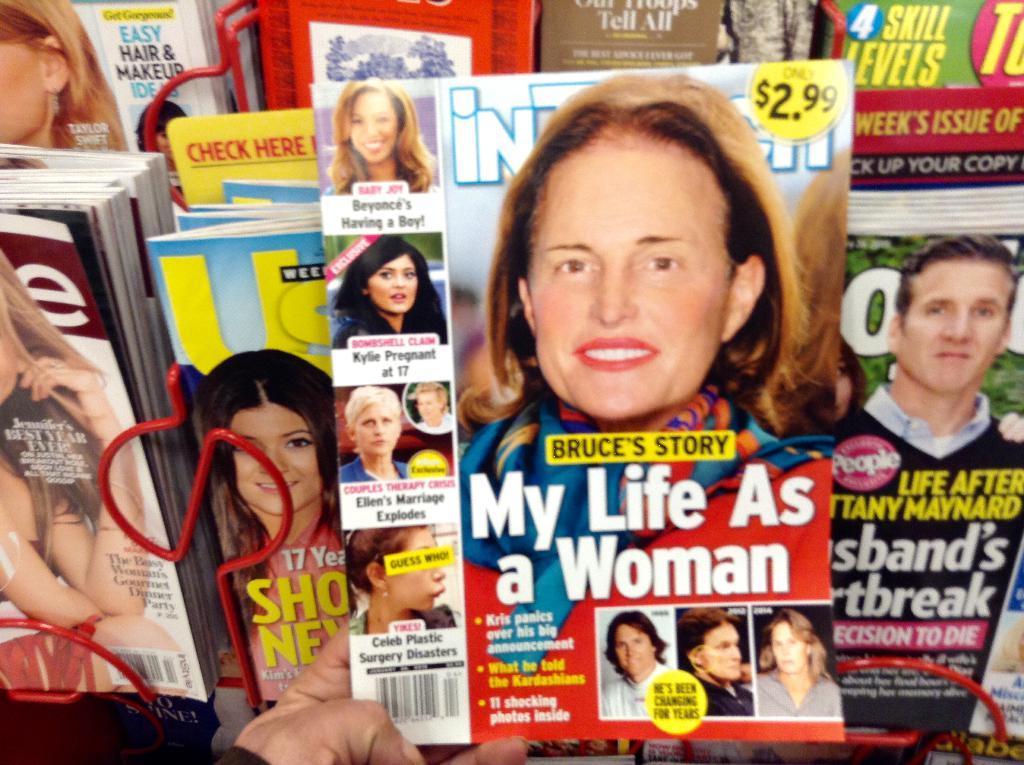Could you give a brief overview of what you see in this image? In the image there are a lot of magazines and a person is holding one of the magazine with the hand. 